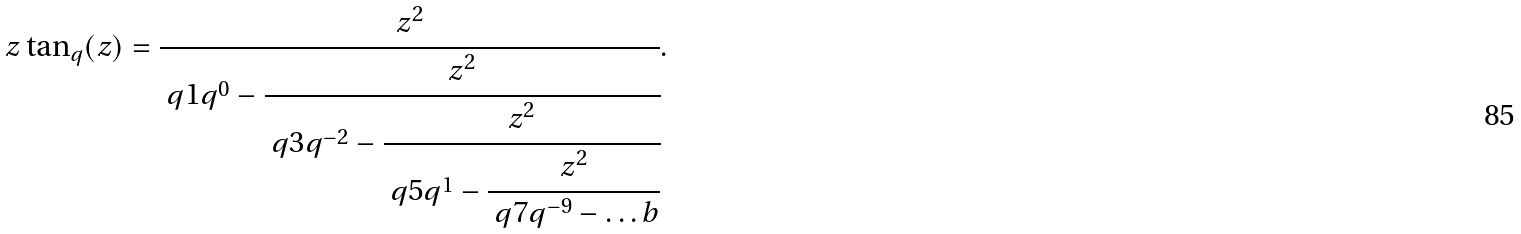<formula> <loc_0><loc_0><loc_500><loc_500>z \tan _ { q } ( z ) = \cfrac { z ^ { 2 } } { \ q { 1 } q ^ { 0 } - \cfrac { z ^ { 2 } } { \ q { 3 } q ^ { - 2 } - \cfrac { z ^ { 2 } } { \ q { 5 } q ^ { 1 } - \cfrac { z ^ { 2 } } { \ q { 7 } q ^ { - 9 } - \dots b } } } } .</formula> 